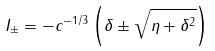<formula> <loc_0><loc_0><loc_500><loc_500>I _ { \pm } = - c ^ { - 1 / 3 } \left ( \delta \pm \sqrt { \eta + \delta ^ { 2 } } \right )</formula> 